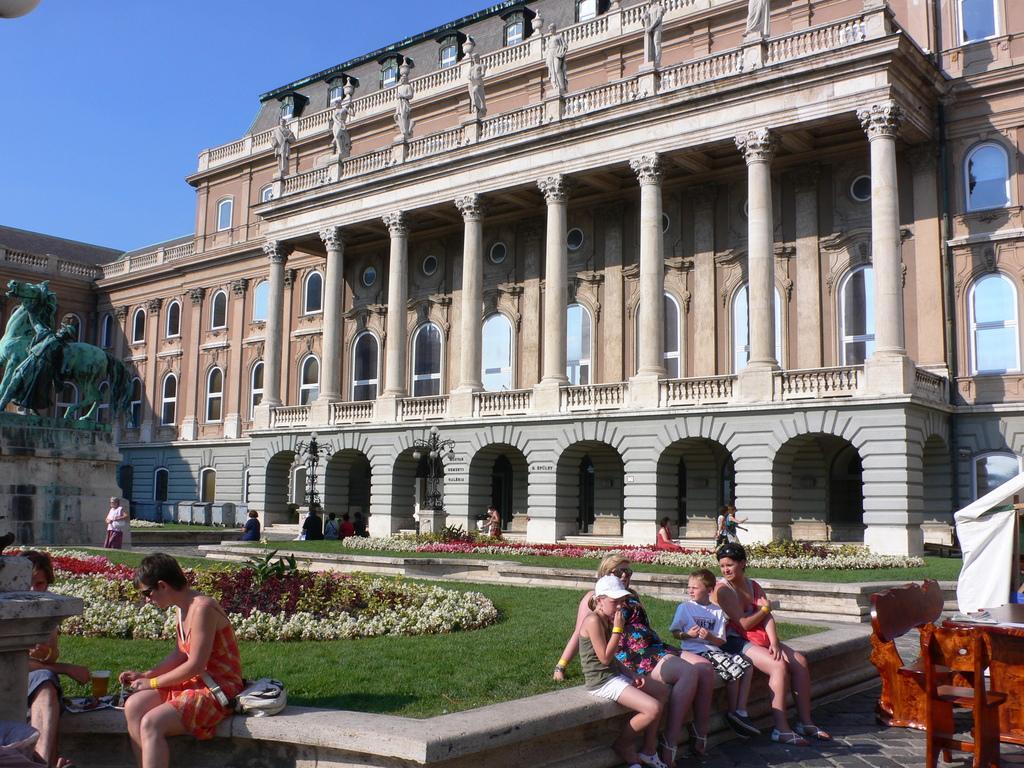Describe this image in one or two sentences. In the image there is a building with walls, pillars, arches and windows. In front of the building there are benches. At the bottom of the image there are few people sitting on the small wall. Behind them there is a garden with grass, plants and flowers. On the left side of the image there is a statue of a horse and a man. In the bottom left corner of the image there is a table and also there are few chairs. At the top of the image there is a sky. 